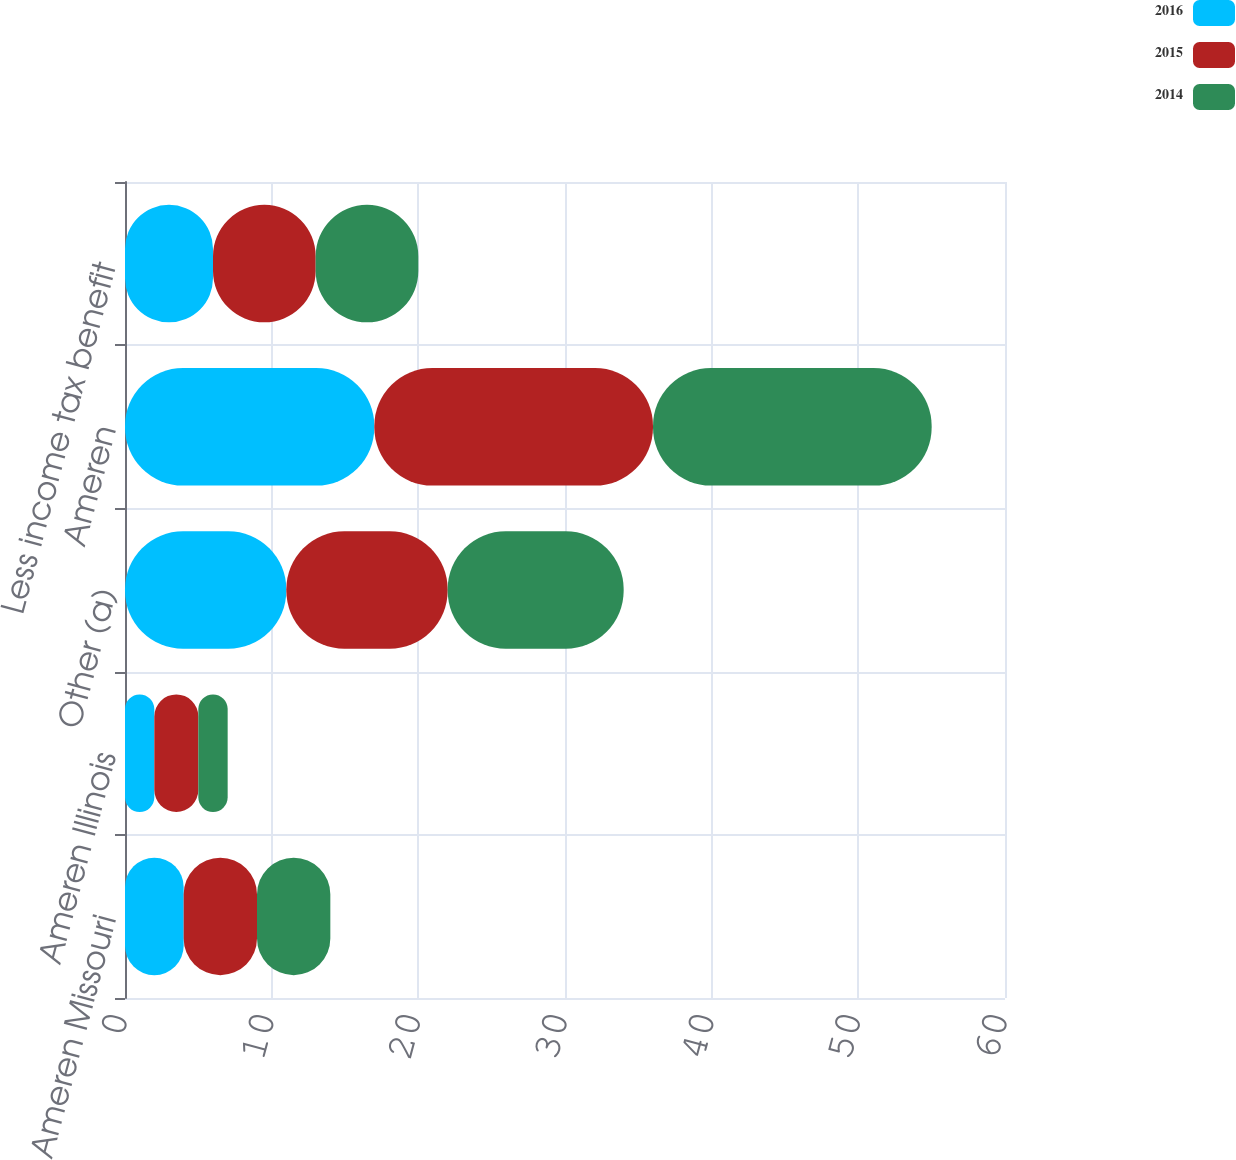Convert chart. <chart><loc_0><loc_0><loc_500><loc_500><stacked_bar_chart><ecel><fcel>Ameren Missouri<fcel>Ameren Illinois<fcel>Other (a)<fcel>Ameren<fcel>Less income tax benefit<nl><fcel>2016<fcel>4<fcel>2<fcel>11<fcel>17<fcel>6<nl><fcel>2015<fcel>5<fcel>3<fcel>11<fcel>19<fcel>7<nl><fcel>2014<fcel>5<fcel>2<fcel>12<fcel>19<fcel>7<nl></chart> 